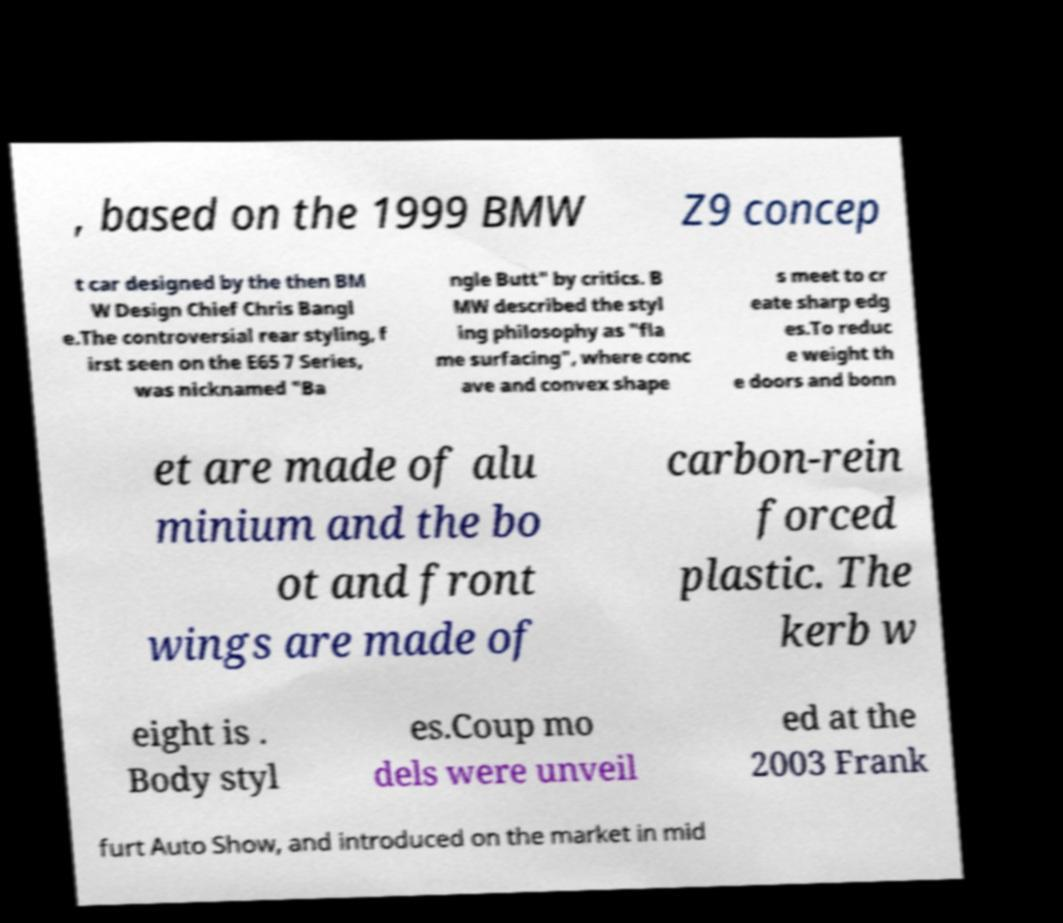Can you accurately transcribe the text from the provided image for me? , based on the 1999 BMW Z9 concep t car designed by the then BM W Design Chief Chris Bangl e.The controversial rear styling, f irst seen on the E65 7 Series, was nicknamed "Ba ngle Butt" by critics. B MW described the styl ing philosophy as "fla me surfacing", where conc ave and convex shape s meet to cr eate sharp edg es.To reduc e weight th e doors and bonn et are made of alu minium and the bo ot and front wings are made of carbon-rein forced plastic. The kerb w eight is . Body styl es.Coup mo dels were unveil ed at the 2003 Frank furt Auto Show, and introduced on the market in mid 